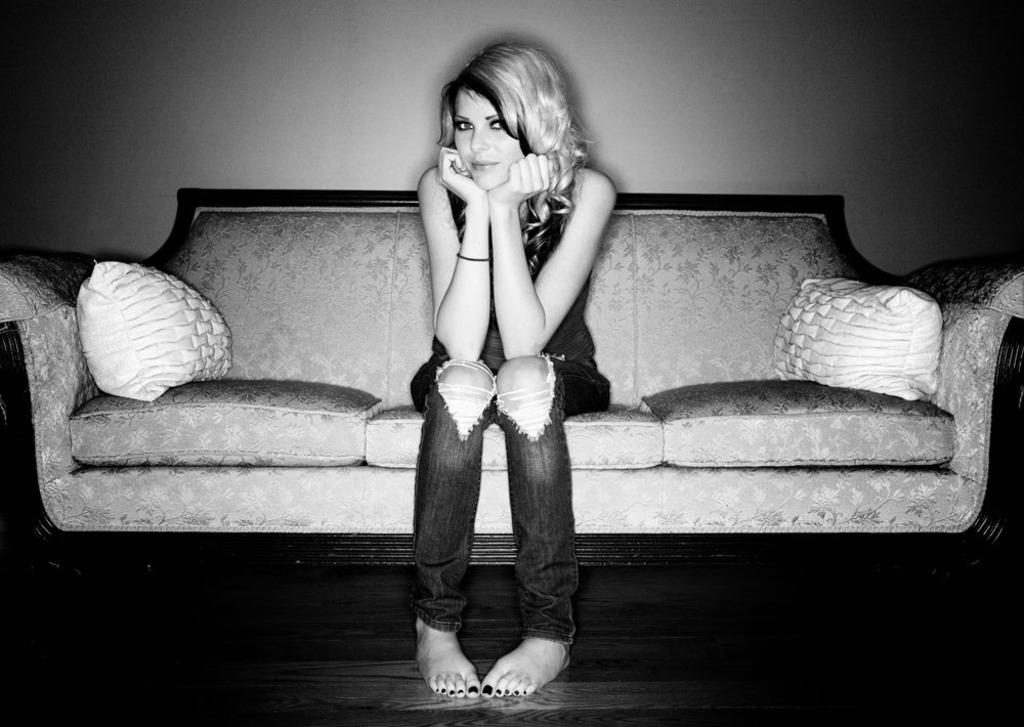How would you summarize this image in a sentence or two? In this image I can see a person sitting on the couch. I can see two pillows and a wall. The image is in black and white. 